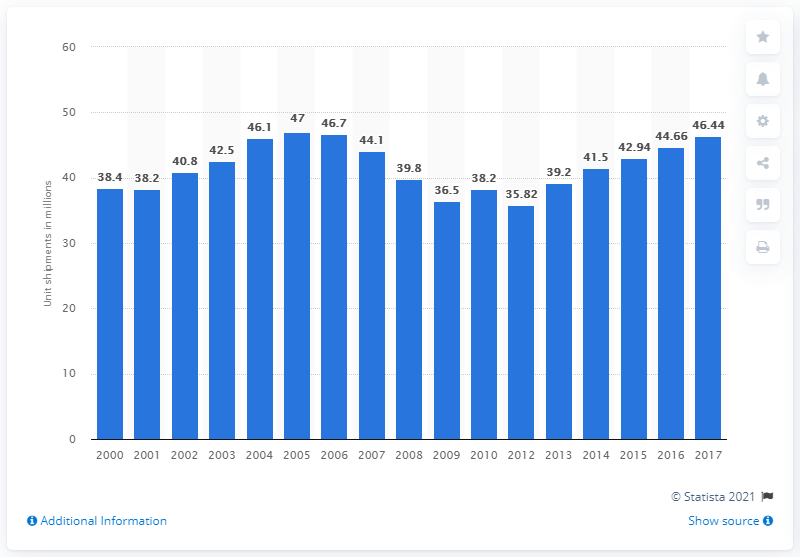Outline some significant characteristics in this image. In 2017, Appliance Magazine predicted unit shipments for core major appliances. The projected total unit shipments of core major appliances for 2015 are estimated to be 42.94. 